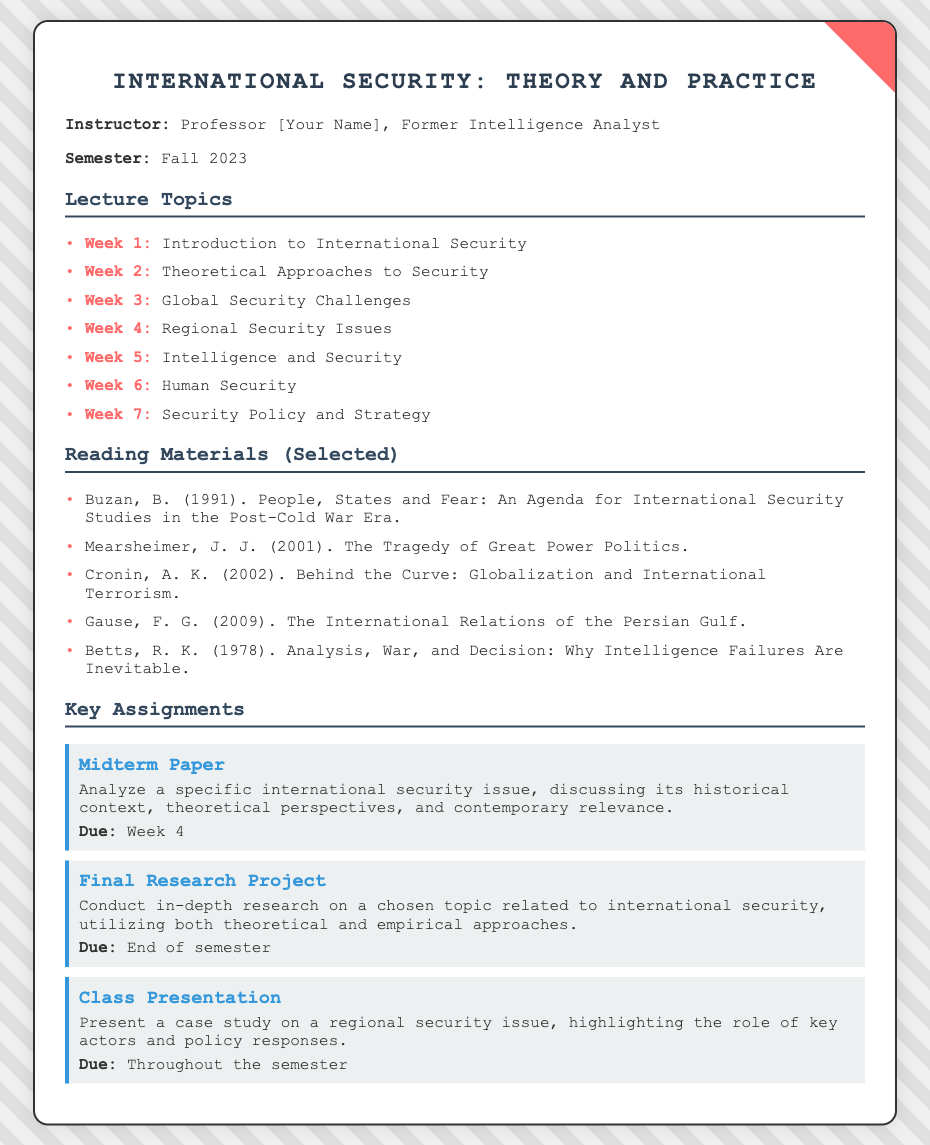what is the title of the course? The title is stated at the top of the document, highlighting the focus on international security.
Answer: International Security: Theory and Practice who is the instructor? The instructor's name is mentioned alongside their background, indicating their expertise in the field.
Answer: Professor [Your Name] which week covers Human Security? This refers to a specific week mentioned in the lecture topics section of the document.
Answer: Week 6 what is due in Week 4? The document outlines assignments with specific due dates, making it clear which are due in Week 4.
Answer: Midterm Paper name one reading material. A list of selected reading materials is provided, and any one of them can be cited as an answer.
Answer: Buzan, B. (1991). People, States and Fear: An Agenda for International Security Studies in the Post-Cold War Era how many key assignments are listed? The number of assignments is a quantifiable aspect mentioned in the document's assignments section.
Answer: Three what type of project is due at the end of the semester? The document specifies the type of major project that students need to submit, clearly defining expectations.
Answer: Final Research Project what is the emphasis of the class presentation? The document describes what students should focus on while preparing for their presentations.
Answer: A case study on a regional security issue which week focuses on Global Security Challenges? This identifies the specific week dedicated to this topic within the lecture schedule.
Answer: Week 3 